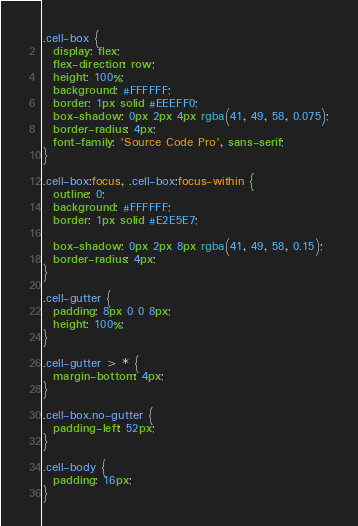<code> <loc_0><loc_0><loc_500><loc_500><_CSS_>.cell-box {
  display: flex;
  flex-direction: row;
  height: 100%;
  background: #FFFFFF;
  border: 1px solid #EEEFF0;
  box-shadow: 0px 2px 4px rgba(41, 49, 58, 0.075);
  border-radius: 4px;
  font-family: 'Source Code Pro', sans-serif;
}

.cell-box:focus, .cell-box:focus-within {
  outline: 0;
  background: #FFFFFF;
  border: 1px solid #E2E5E7;

  box-shadow: 0px 2px 8px rgba(41, 49, 58, 0.15);
  border-radius: 4px;
}

.cell-gutter {
  padding: 8px 0 0 8px;
  height: 100%;
}

.cell-gutter > * {
  margin-bottom: 4px;
}

.cell-box.no-gutter {
  padding-left: 52px;
}

.cell-body {
  padding: 16px;
}</code> 